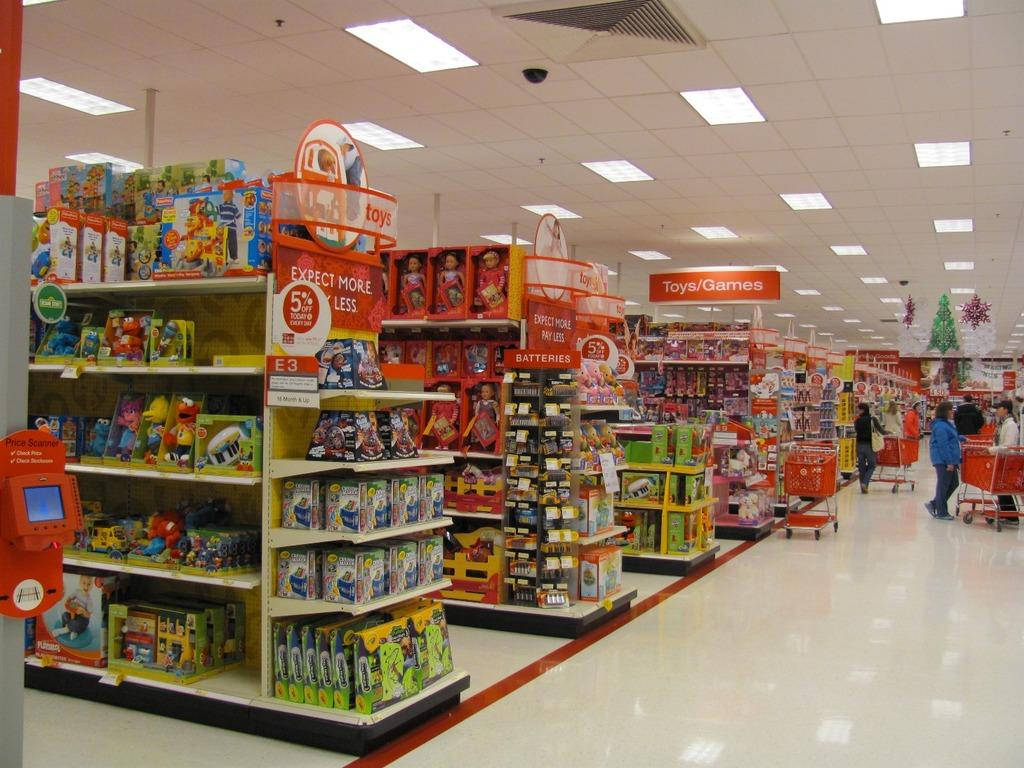<image>
Share a concise interpretation of the image provided. A large store in which the toys and games section is up ahead on the left. 